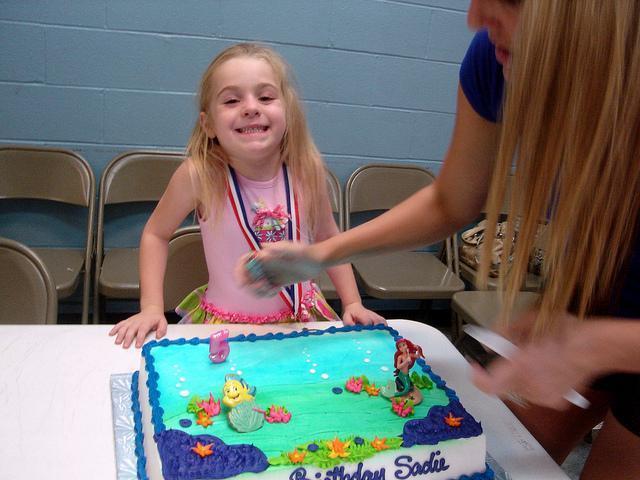How many children are there?
Give a very brief answer. 1. How many chairs are there?
Give a very brief answer. 6. How many people are there?
Give a very brief answer. 2. 